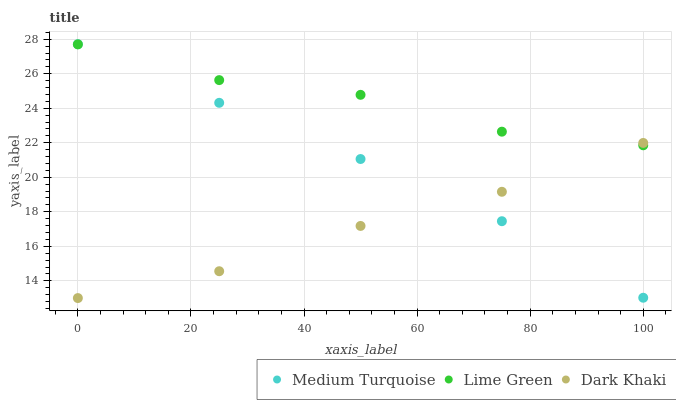Does Dark Khaki have the minimum area under the curve?
Answer yes or no. Yes. Does Lime Green have the maximum area under the curve?
Answer yes or no. Yes. Does Medium Turquoise have the minimum area under the curve?
Answer yes or no. No. Does Medium Turquoise have the maximum area under the curve?
Answer yes or no. No. Is Medium Turquoise the smoothest?
Answer yes or no. Yes. Is Lime Green the roughest?
Answer yes or no. Yes. Is Lime Green the smoothest?
Answer yes or no. No. Is Medium Turquoise the roughest?
Answer yes or no. No. Does Dark Khaki have the lowest value?
Answer yes or no. Yes. Does Medium Turquoise have the lowest value?
Answer yes or no. No. Does Medium Turquoise have the highest value?
Answer yes or no. Yes. Does Lime Green have the highest value?
Answer yes or no. No. Does Medium Turquoise intersect Lime Green?
Answer yes or no. Yes. Is Medium Turquoise less than Lime Green?
Answer yes or no. No. Is Medium Turquoise greater than Lime Green?
Answer yes or no. No. 